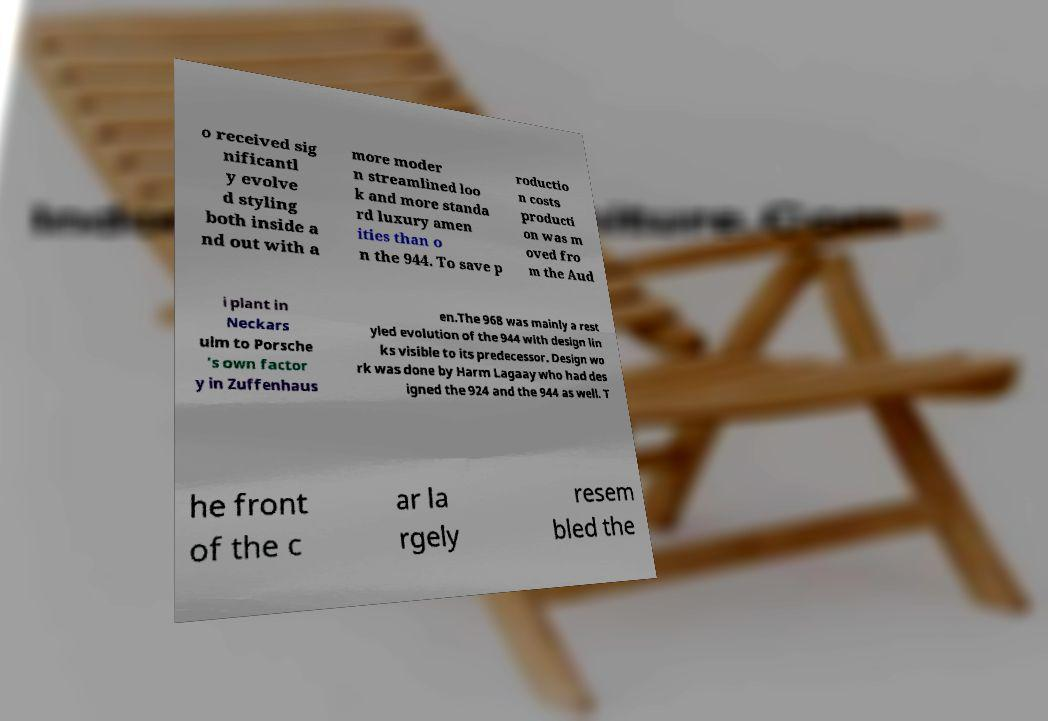Could you extract and type out the text from this image? o received sig nificantl y evolve d styling both inside a nd out with a more moder n streamlined loo k and more standa rd luxury amen ities than o n the 944. To save p roductio n costs producti on was m oved fro m the Aud i plant in Neckars ulm to Porsche 's own factor y in Zuffenhaus en.The 968 was mainly a rest yled evolution of the 944 with design lin ks visible to its predecessor. Design wo rk was done by Harm Lagaay who had des igned the 924 and the 944 as well. T he front of the c ar la rgely resem bled the 